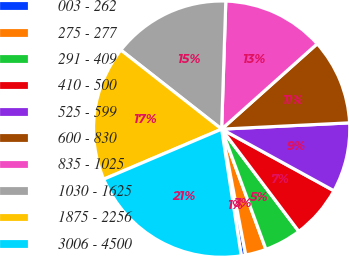<chart> <loc_0><loc_0><loc_500><loc_500><pie_chart><fcel>003 - 262<fcel>275 - 277<fcel>291 - 409<fcel>410 - 500<fcel>525 - 599<fcel>600 - 830<fcel>835 - 1025<fcel>1030 - 1625<fcel>1875 - 2256<fcel>3006 - 4500<nl><fcel>0.56%<fcel>2.61%<fcel>4.67%<fcel>6.72%<fcel>8.77%<fcel>10.82%<fcel>12.88%<fcel>14.93%<fcel>16.98%<fcel>21.06%<nl></chart> 